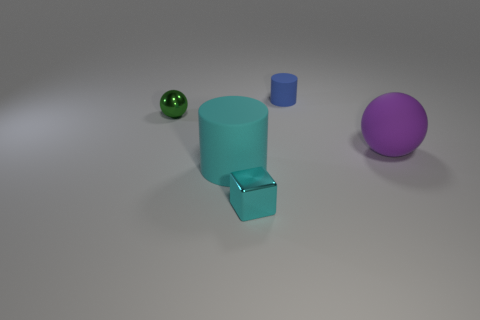Add 3 cyan rubber cylinders. How many objects exist? 8 Subtract 1 cubes. How many cubes are left? 0 Subtract all cylinders. How many objects are left? 3 Subtract all large cylinders. Subtract all big purple metallic objects. How many objects are left? 4 Add 4 small blue cylinders. How many small blue cylinders are left? 5 Add 3 tiny shiny cubes. How many tiny shiny cubes exist? 4 Subtract 0 brown balls. How many objects are left? 5 Subtract all green balls. Subtract all gray cylinders. How many balls are left? 1 